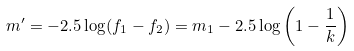Convert formula to latex. <formula><loc_0><loc_0><loc_500><loc_500>m ^ { \prime } = - 2 . 5 \log ( f _ { 1 } - f _ { 2 } ) = m _ { 1 } - 2 . 5 \log \left ( 1 - \frac { 1 } { k } \right )</formula> 